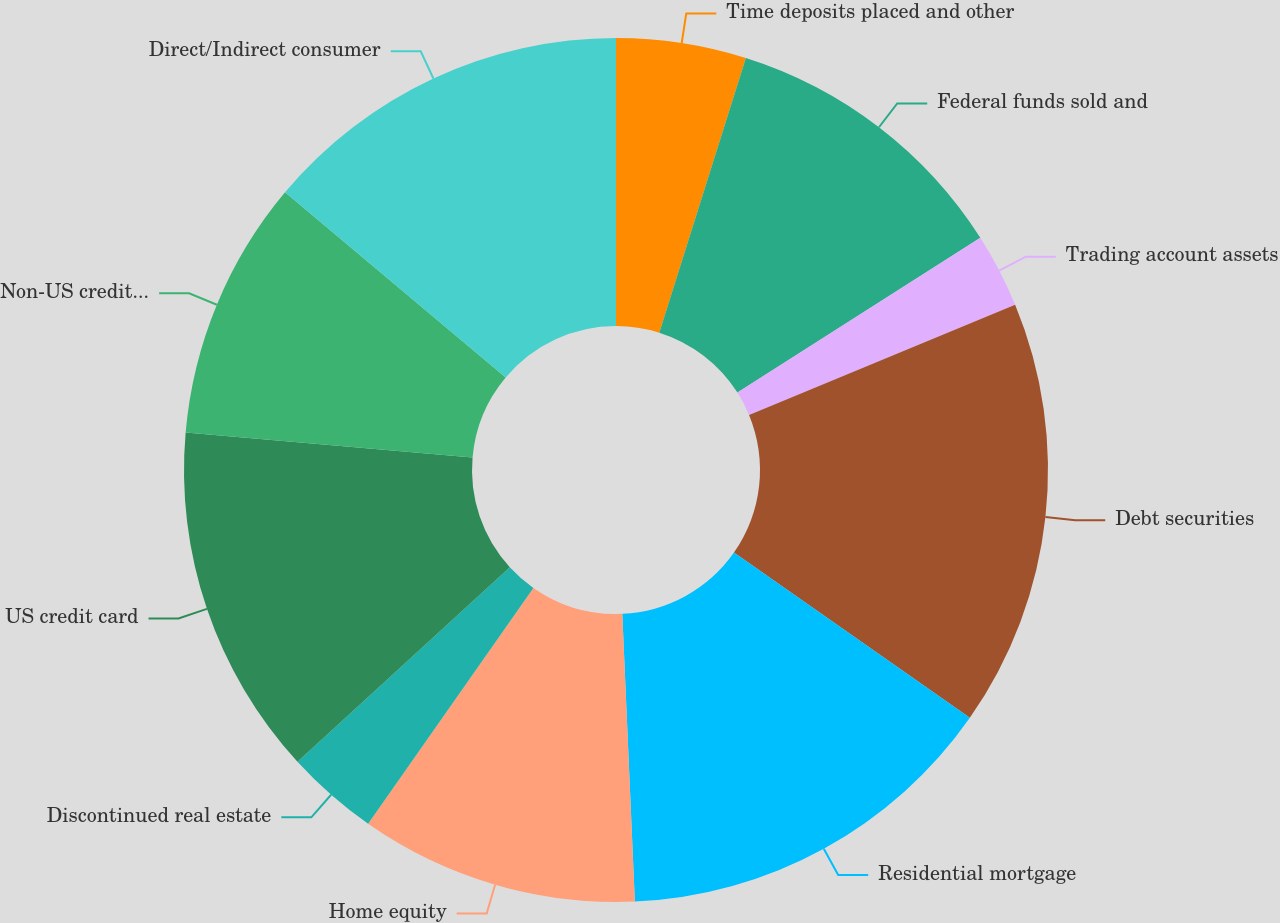<chart> <loc_0><loc_0><loc_500><loc_500><pie_chart><fcel>Time deposits placed and other<fcel>Federal funds sold and<fcel>Trading account assets<fcel>Debt securities<fcel>Residential mortgage<fcel>Home equity<fcel>Discontinued real estate<fcel>US credit card<fcel>Non-US credit card<fcel>Direct/Indirect consumer<nl><fcel>4.86%<fcel>11.11%<fcel>2.78%<fcel>15.97%<fcel>14.58%<fcel>10.42%<fcel>3.47%<fcel>13.19%<fcel>9.72%<fcel>13.89%<nl></chart> 